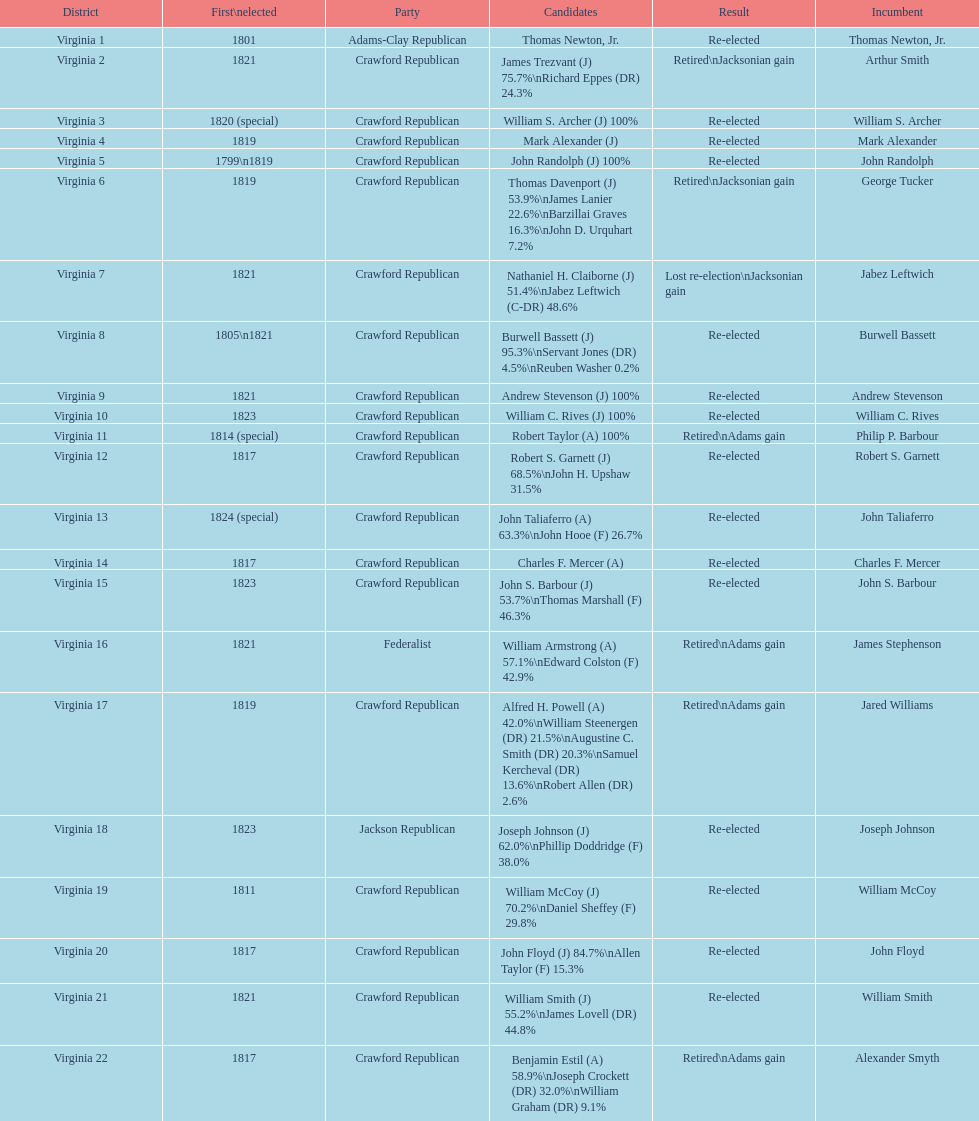Tell me the number of people first elected in 1817. 4. 